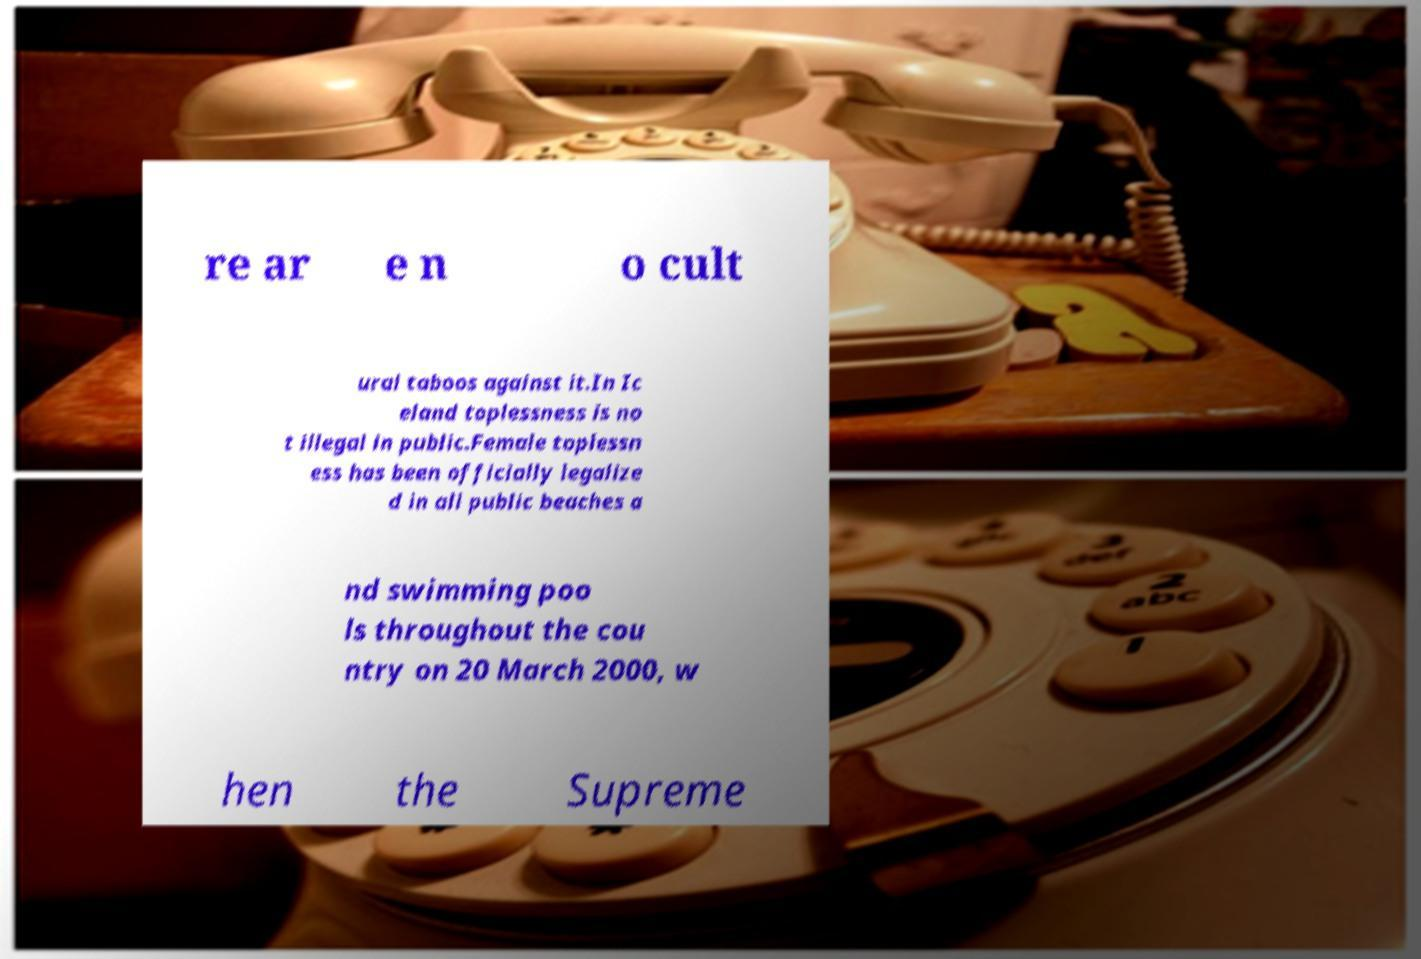Please identify and transcribe the text found in this image. re ar e n o cult ural taboos against it.In Ic eland toplessness is no t illegal in public.Female toplessn ess has been officially legalize d in all public beaches a nd swimming poo ls throughout the cou ntry on 20 March 2000, w hen the Supreme 